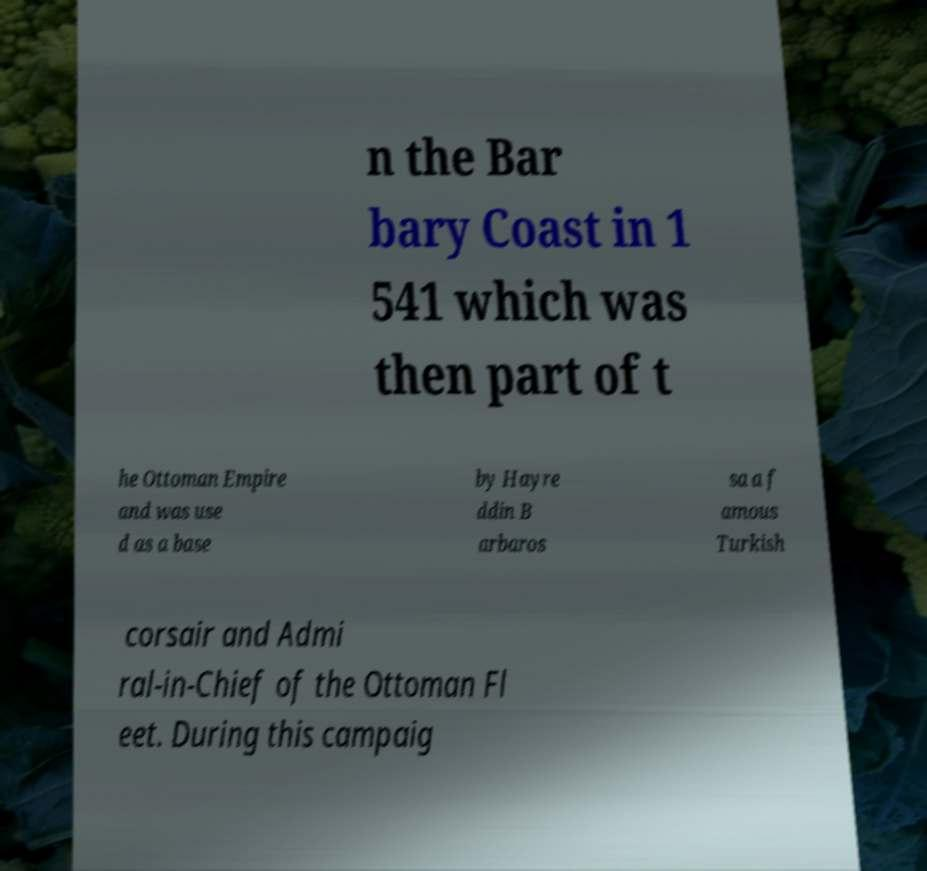Can you accurately transcribe the text from the provided image for me? n the Bar bary Coast in 1 541 which was then part of t he Ottoman Empire and was use d as a base by Hayre ddin B arbaros sa a f amous Turkish corsair and Admi ral-in-Chief of the Ottoman Fl eet. During this campaig 